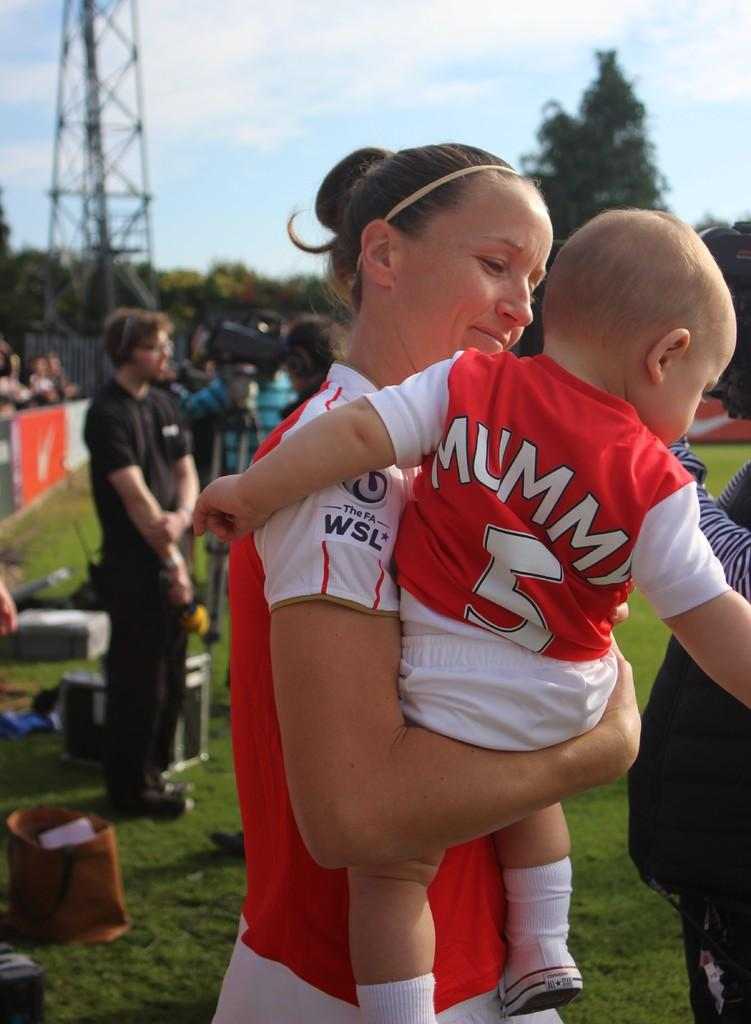<image>
Render a clear and concise summary of the photo. a baby and a mother that has Mummy on the shirt 